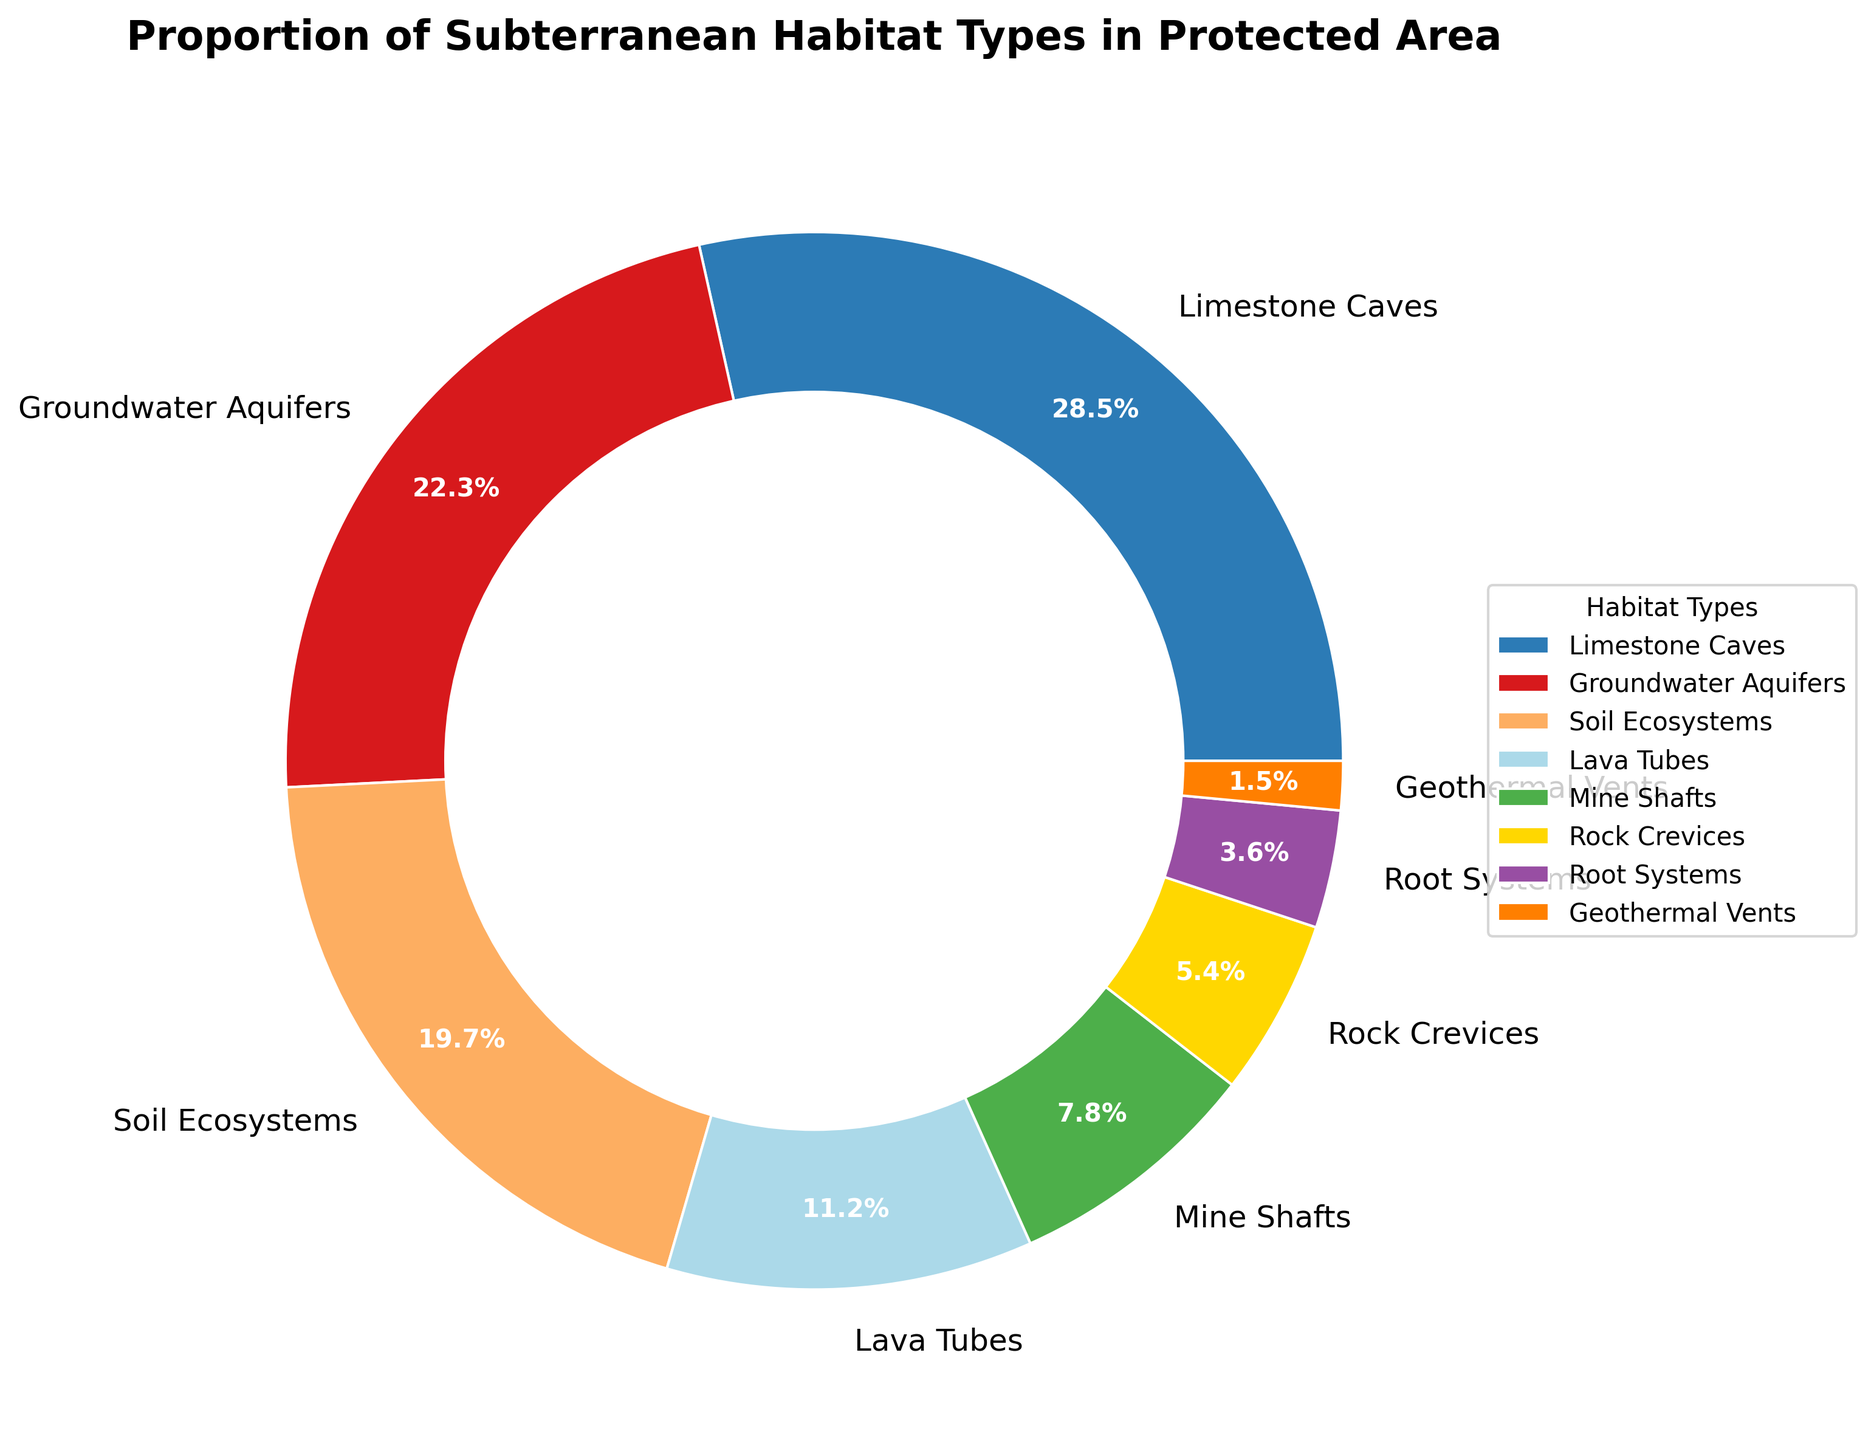Which subterranean habitat type has the highest proportion? By visually inspecting the pie chart, we identify the segment with the largest size. The label corresponding to this segment indicates the subterranean habitat type with the highest proportion.
Answer: Limestone Caves Which two habitat types together make up more than 50% of the protected area? To find the answer, look for the top two largest segments in the pie chart and sum their percentages. Limestone Caves (28.5%) and Groundwater Aquifers (22.3%) give us 28.5% + 22.3% = 50.8%.
Answer: Limestone Caves and Groundwater Aquifers How does the proportion of Soil Ecosystems compare to Lava Tubes? By comparing the sizes of the segments labeled Soil Ecosystems and Lava Tubes or by examining their respective percentages, we see that Soil Ecosystems (19.7%) is larger than Lava Tubes (11.2%).
Answer: Soil Ecosystems has a higher proportion than Lava Tubes What is the combined percentage of Rock Crevices and Root Systems? Adding the percentages of Rock Crevices (5.4%) and Root Systems (3.6%) gives us a combined total of 5.4% + 3.6% = 9.0%.
Answer: 9.0% Which habitat type has the smallest proportion and what is its percentage? The smallest segment in the pie chart represents the habitat type with the lowest proportion, which is the segment labeled Geothermal Vents with a percentage of 1.5%.
Answer: Geothermal Vents, 1.5% Are there more Lava Tubes or Mine Shafts in the protected area, based on the percentage? By comparing the percentages directly, we see that Lava Tubes (11.2%) have a larger share than Mine Shafts (7.8%).
Answer: Lava Tubes What percentage of the protected area is occupied by habitats other than Limestone Caves and Groundwater Aquifers? Subtract the sum of the percentages of Limestone Caves (28.5%) and Groundwater Aquifers (22.3%) from 100%. So, 100% - 28.5% - 22.3% = 49.2%.
Answer: 49.2% How do the combined proportions of Groundwater Aquifers and Mine Shafts compare to Limestone Caves alone? Combining Groundwater Aquifers (22.3%) and Mine Shafts (7.8%) gives 22.3% + 7.8% = 30.1%. Since 30.1% is greater than Limestone Caves' 28.5%, the combined proportion is higher.
Answer: Combined proportions of Groundwater Aquifers and Mine Shafts are higher than Limestone Caves Among the habitat types, which are shown in blue and purple segments respectively? By examining the color segments in the pie chart, the blue segment represents Limestone Caves and the purple segment represents Rock Crevices.
Answer: Limestone Caves and Rock Crevices 